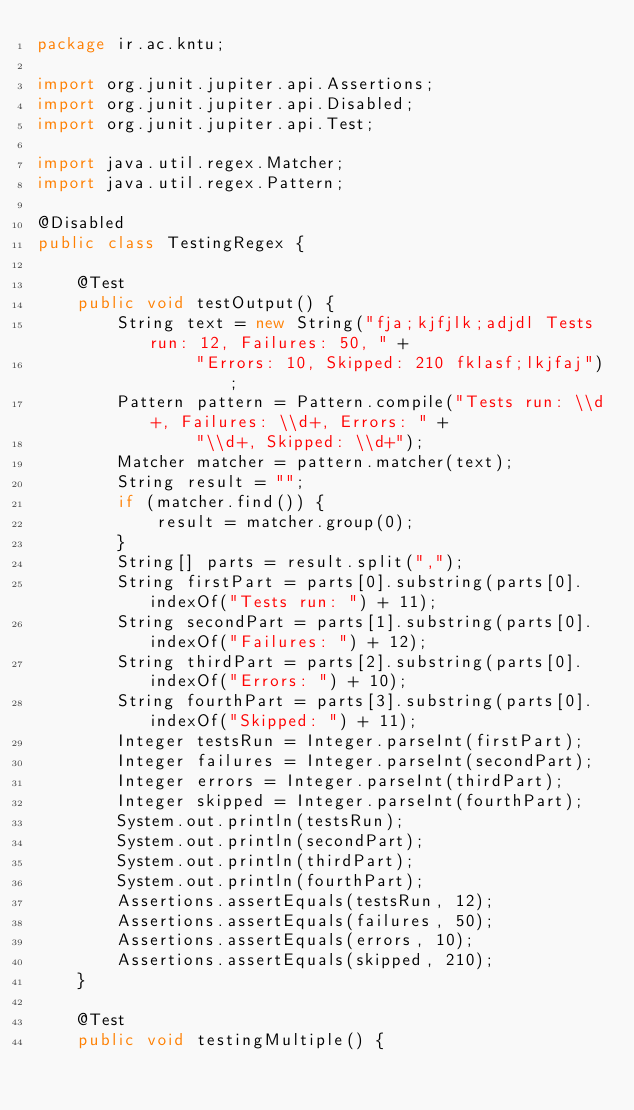Convert code to text. <code><loc_0><loc_0><loc_500><loc_500><_Java_>package ir.ac.kntu;

import org.junit.jupiter.api.Assertions;
import org.junit.jupiter.api.Disabled;
import org.junit.jupiter.api.Test;

import java.util.regex.Matcher;
import java.util.regex.Pattern;

@Disabled
public class TestingRegex {

    @Test
    public void testOutput() {
        String text = new String("fja;kjfjlk;adjdl Tests run: 12, Failures: 50, " +
                "Errors: 10, Skipped: 210 fklasf;lkjfaj");
        Pattern pattern = Pattern.compile("Tests run: \\d+, Failures: \\d+, Errors: " +
                "\\d+, Skipped: \\d+");
        Matcher matcher = pattern.matcher(text);
        String result = "";
        if (matcher.find()) {
            result = matcher.group(0);
        }
        String[] parts = result.split(",");
        String firstPart = parts[0].substring(parts[0].indexOf("Tests run: ") + 11);
        String secondPart = parts[1].substring(parts[0].indexOf("Failures: ") + 12);
        String thirdPart = parts[2].substring(parts[0].indexOf("Errors: ") + 10);
        String fourthPart = parts[3].substring(parts[0].indexOf("Skipped: ") + 11);
        Integer testsRun = Integer.parseInt(firstPart);
        Integer failures = Integer.parseInt(secondPart);
        Integer errors = Integer.parseInt(thirdPart);
        Integer skipped = Integer.parseInt(fourthPart);
        System.out.println(testsRun);
        System.out.println(secondPart);
        System.out.println(thirdPart);
        System.out.println(fourthPart);
        Assertions.assertEquals(testsRun, 12);
        Assertions.assertEquals(failures, 50);
        Assertions.assertEquals(errors, 10);
        Assertions.assertEquals(skipped, 210);
    }

    @Test
    public void testingMultiple() {</code> 